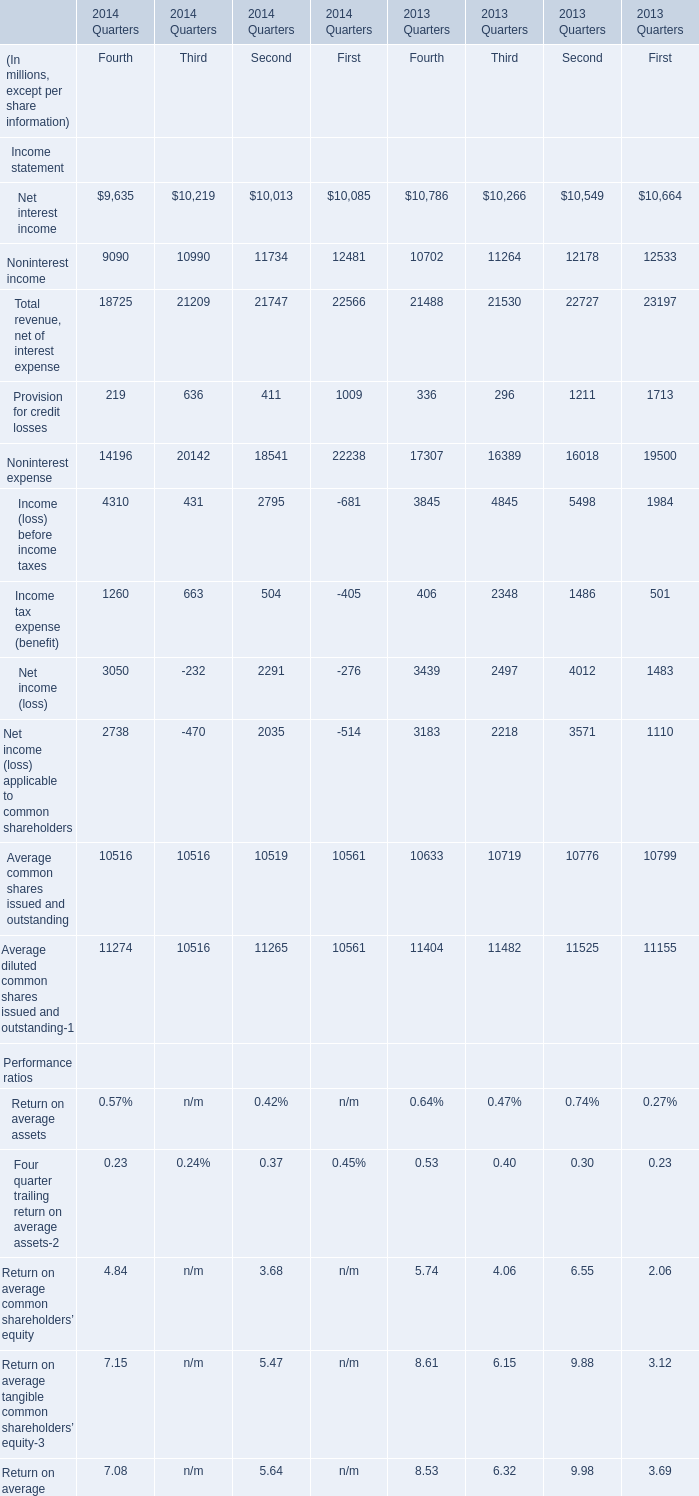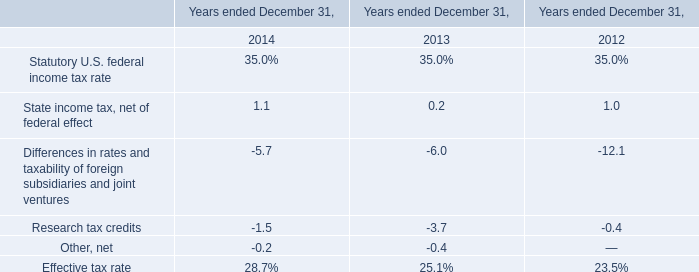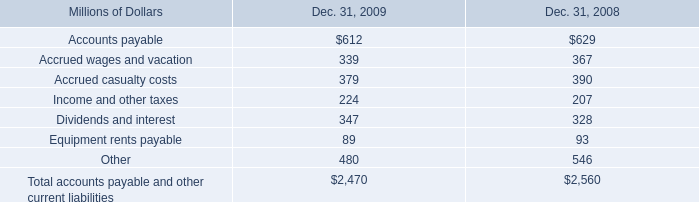What is the sum of Net interest income for Fourth and State income tax, net of federal effect in 2014? (in million) 
Computations: (9635 + 1.1)
Answer: 9636.1. What's the total amount of the Net interest income in the years where Noninterest income is greater than 12500? (in million) 
Computations: (((10786 + 10266) + 10549) + 10664)
Answer: 42265.0. 